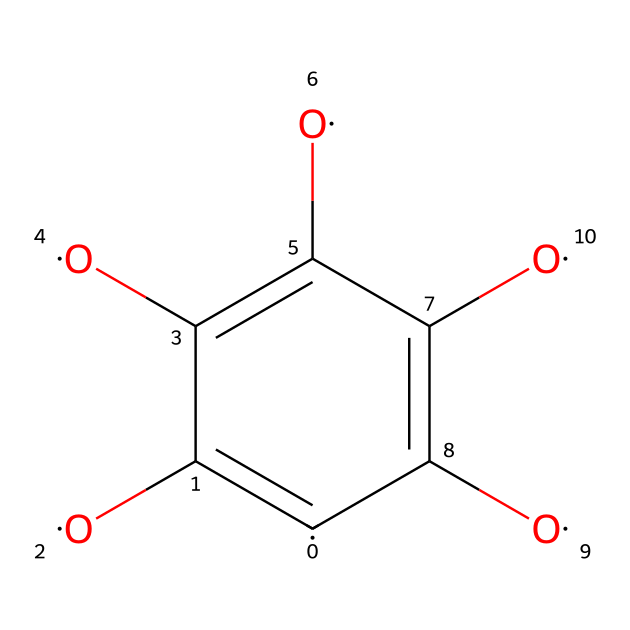What is the molecular formula of graphene oxide represented by this SMILES? The SMILES representation suggests the composition of the molecule, including carbon (C) and oxygen (O) atoms. By analyzing the structure, one can determine there are 6 carbon atoms and 4 oxygen atoms present. Therefore, the molecular formula can be derived as C6O4.
Answer: C6O4 How many carbon atoms are present in this chemical? The SMILES notation displays the arrangement of carbon atoms. By counting the 'C' symbols in the structure, we note there are 6 carbon atoms in total.
Answer: 6 What type of bonds are present between the carbon atoms? Analyzing the structure indicated by the SMILES, we can see that the carbon atoms are involved in alternating double bonds and single bonds, characteristic of aromatic compounds. The structure implies that they are connected through both single and double bonds.
Answer: single and double bonds What is the oxidation state of the oxygen atoms in this structure? The presence of multiple –OH (hydroxyl) groups and carbonyl groups in the structure, from the SMILES, indicates that the oxygen atoms are in a higher oxidation state, typically -2. This suggests that the oxygen is mostly in a reduced form rather than in elemental form.
Answer: -2 How does graphene oxide contribute to electronics cooling? The structure of graphene oxide with its high surface area and excellent thermal conductivity allows for efficient heat dissipation in electronic devices, making it suitable for applications in advanced electronics cooling.
Answer: heat dissipation What is the primary function of the hydroxyl groups in the structure? The hydroxyl groups (-OH) in the graphene oxide structure increase its hydrophilicity, which is crucial for enhancing interactions with other materials used in electronic systems and facilitating better thermal management.
Answer: hydrophilicity Is this chemical considered a conductive material? While graphene oxide itself displays reduced conductivity compared to pure graphene due to its functional groups, it often can be engineered to improve its conductive properties, particularly when used in nanomaterials for electronics.
Answer: yes 